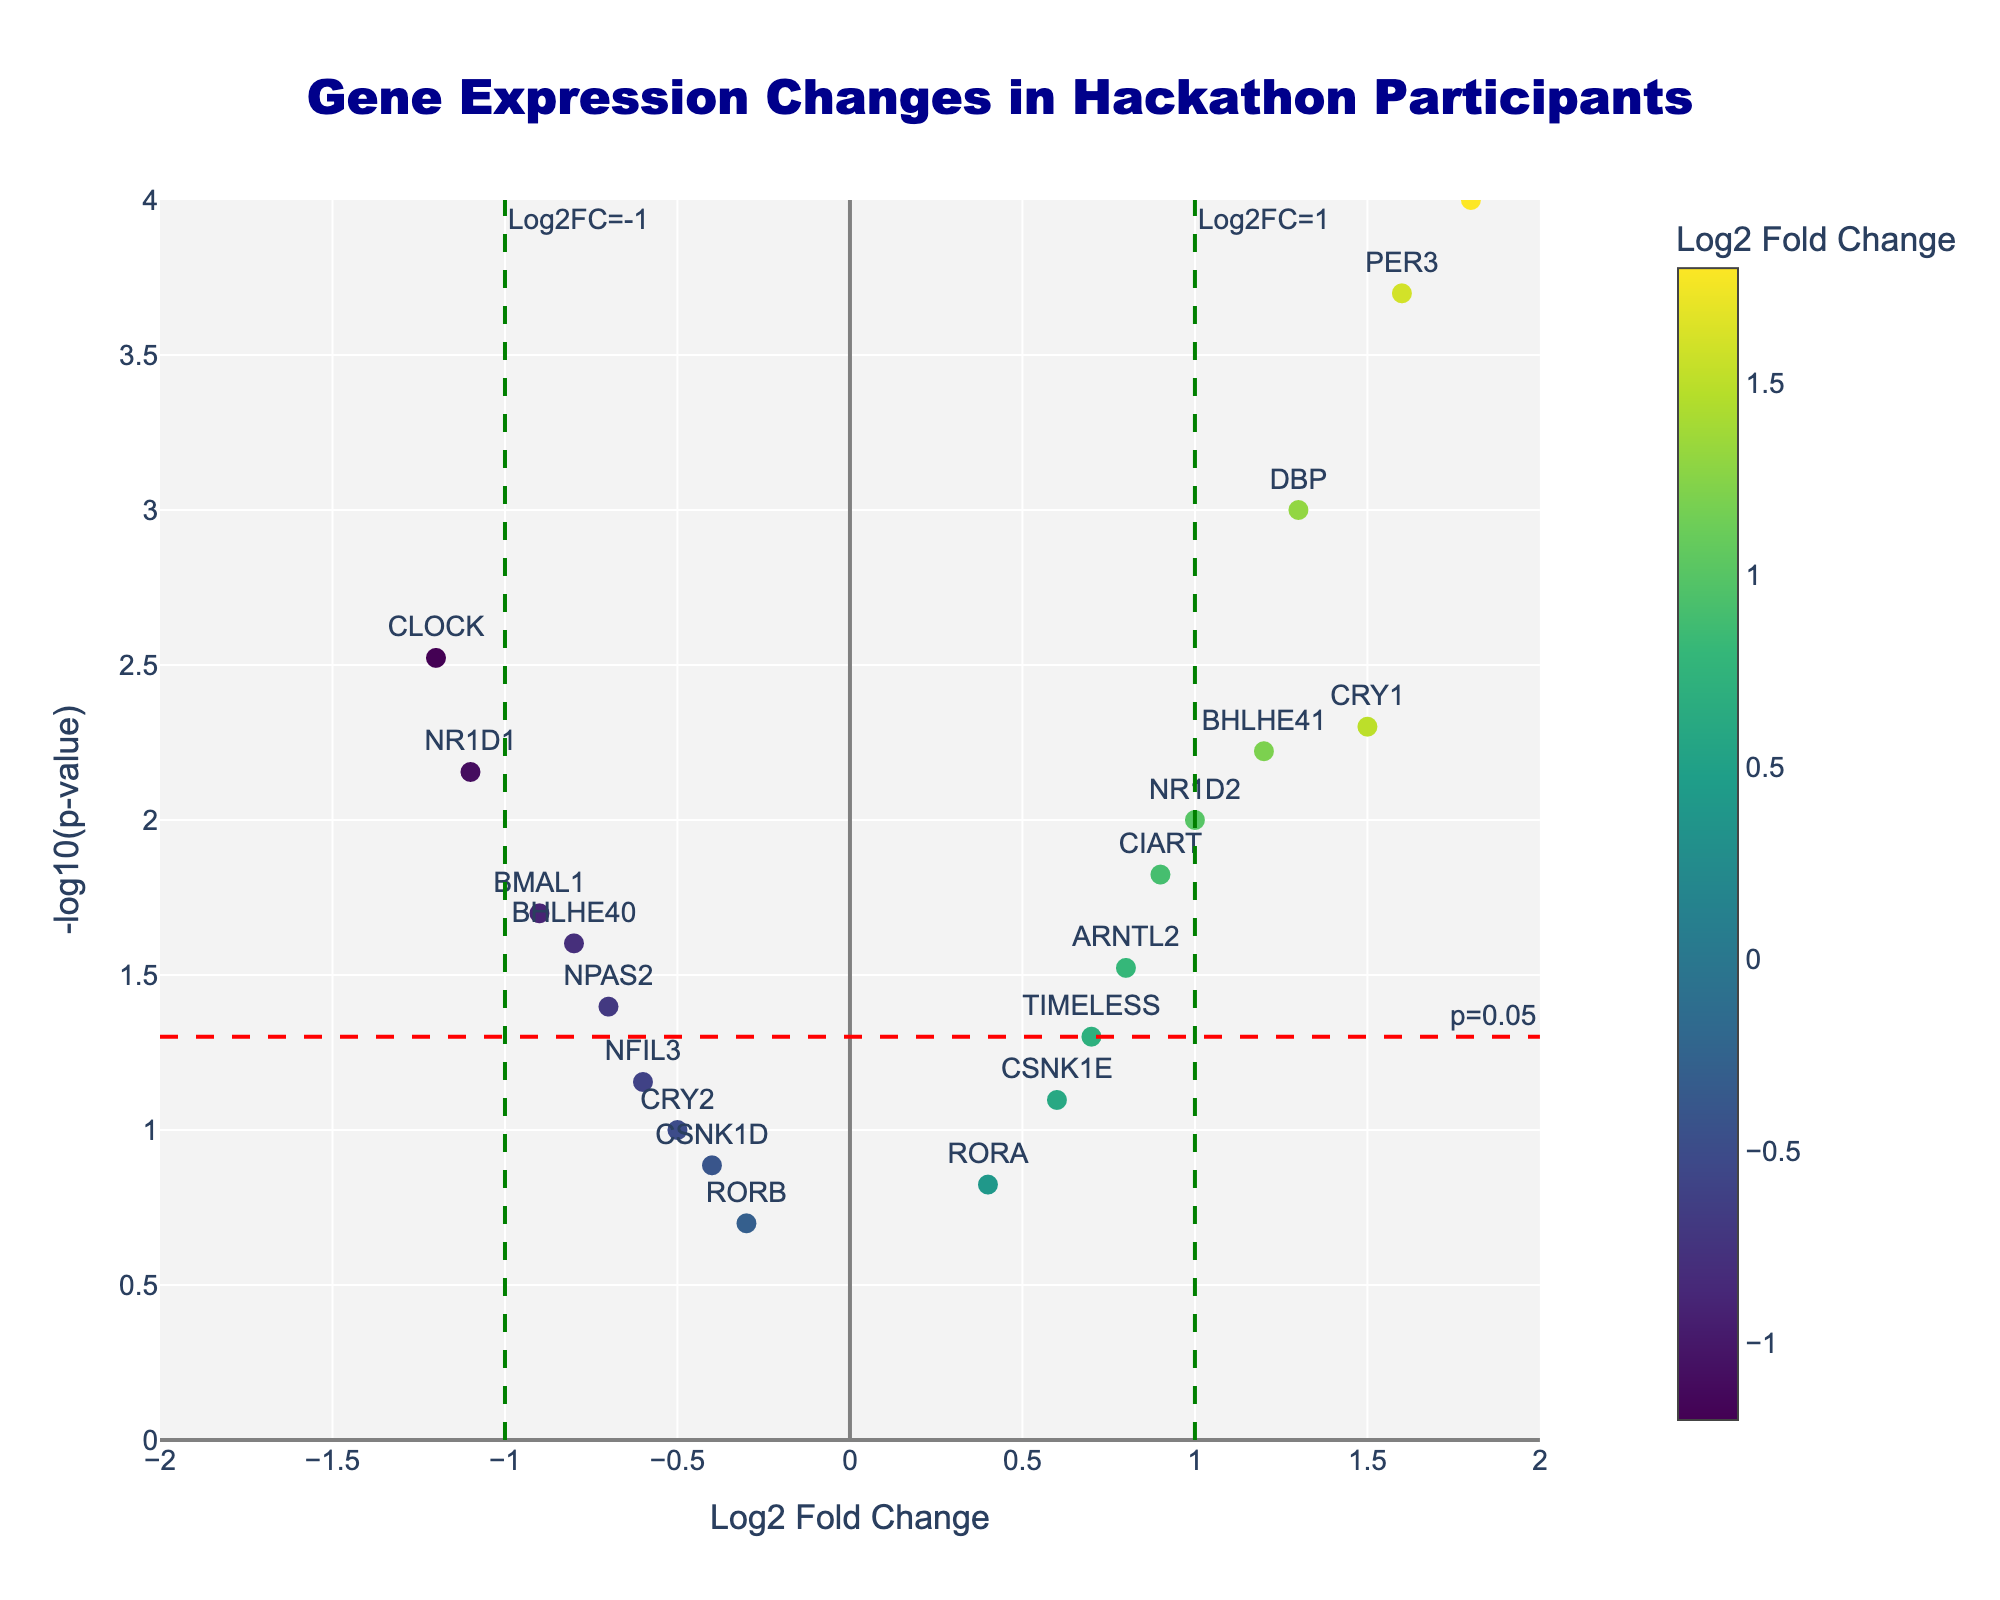How many genes have a Log2FoldChange greater than 1? To find the number of genes with Log2FoldChange greater than 1, identify the markers on the plot with x-values greater than 1. Count these markers. Genes with Log2FoldChange greater than 1 are PER2, PER3, and DBP.
Answer: 3 Which gene has the lowest p-value? Look for the gene with the highest y-value on the plot, as this corresponds to the lowest p-value (since y-axis is -log10(p-value)). PER2 has the highest y-value.
Answer: PER2 What is the Log2FoldChange and p-value of the gene CSNK1E? Hover over or locate the marker labeled "CSNK1E" on the plot to find its corresponding Log2FoldChange and p-value. The hover text will show: Log2FC: 0.6, p-value: 0.08.
Answer: Log2FC: 0.6, p-value: 0.08 Are there any genes with a p-value greater than 0.05 and Log2FoldChange less than -1? Identify markers in the region where x-values are less than -1 and y-values are less than -log10(0.05). NR1D1 has a Log2FoldChange less than -1, but its p-value is less than 0.05, which does not meet the condition. No genes match the criteria.
Answer: No Which gene has the highest Log2FoldChange while being statistically significant (p < 0.05)? Look for the marker with the highest x-value among those above the horizontal line at y = -log10(0.05). PER2 has the highest Log2FoldChange (1.8) with a p-value < 0.05.
Answer: PER2 How many genes have a p-value less than 0.01? Count all the markers above the horizontal line at y = -log10(0.01). Genes with p-values less than 0.01 are PER2, CRY1, DBP, NR1D1, PER3, BHLHE41, and CIART.
Answer: 7 Which gene lies closest to the origin (Log2FoldChange = 0, p-value = 1)? Identify the marker closest to the point (0, 0) using both x and y coordinates. RORA, with Log2FoldChange of 0.4 and a p-value of 0.15, appears to be the closest.
Answer: RORA What is the range of -log10(p-value) observed in the plot? Identify the minimum and maximum y-values on the plot. The lowest value is for RORB at approximately -log10(0.2) ~ 0.7, and the highest is for PER2 at -log10(0.0001) = 4. The range is 0.7 to 4.
Answer: 0.7 to 4 Between CRY1 and CRY2, which one is more statistically significant? Compare the y-values of CRY1 and CRY2. The higher the y-value (-log10(p-value)), the more statistically significant. CRY1 has a higher y-value compared to CRY2.
Answer: CRY1 